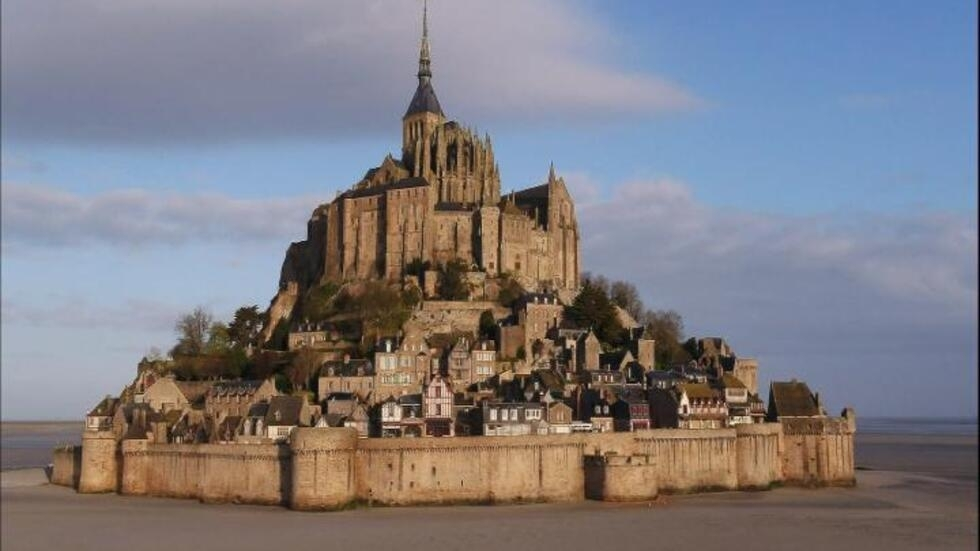What can you tell me about the history of this place? Mont Saint-Michel has a rich history dating back to the 8th century when it was first established as a small, rocky islet. Originally dedicated to the Archangel Michael, the site evolved into an important pilgrimage destination during the Middle Ages. The abbey's construction began in the 10th century and continued for several centuries, resulting in a complex blend of Gothic, Romanesque, and Norman architectural styles. The fortified walls were added as a defense mechanism, notably withstanding multiple sieges during the Hundred Years' War. Over time, Mont Saint-Michel also served as a prison during the French Revolution and was later restored to its former glory. Today, it remains one of France’s most visited landmarks, celebrated for its historical, cultural, and architectural significance. What is it like to visit Mont Saint-Michel today? Visiting Mont Saint-Michel today is like stepping back in time. The journey usually starts with a picturesque walk along the causeway that connects the island to the mainland. As you approach, the towering spires and stone fortifications become more imposing, creating a sense of awe. Once inside the gates, narrow cobblestone streets wind through the small village lined with quaint shops, cafes, and museums. The highlight of the visit is undoubtedly the abbey, with its grand halls, intricate architecture, and breathtaking views of the surrounding bay. Many visitors also time their visit to witness the dramatic tidal changes, which further enhance the mystical atmosphere of the island. Whether exploring its historical sites or simply soaking in the views, Mont Saint-Michel offers a unique and unforgettable experience. Imagine Mont Saint-Michel during a legend-filled folklore festival. What would that be like? Picture Mont Saint-Michel enveloped in the mysticism of a folklore festival, where the streets buzz with the sound of traditional music and the laughter of storytellers sharing tales of mythical creatures and heroic knights. Lanterns cast a warm, flickering light along the cobblestone streets, where vendors sell handcrafted goods and delicious local delicacies. Costumed performers reenact historical battles and legendary events, bringing the past to life against the backdrop of the grand abbey. As dusk falls, a grand procession winds its way through the village, heading towards the abbey for a spectacular light show projected onto its ancient walls. The atmosphere is both magical and enchanting, transforming Mont Saint-Michel into a realm where history and fantasy intertwine. 